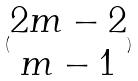Convert formula to latex. <formula><loc_0><loc_0><loc_500><loc_500>( \begin{matrix} 2 m - 2 \\ m - 1 \end{matrix} )</formula> 